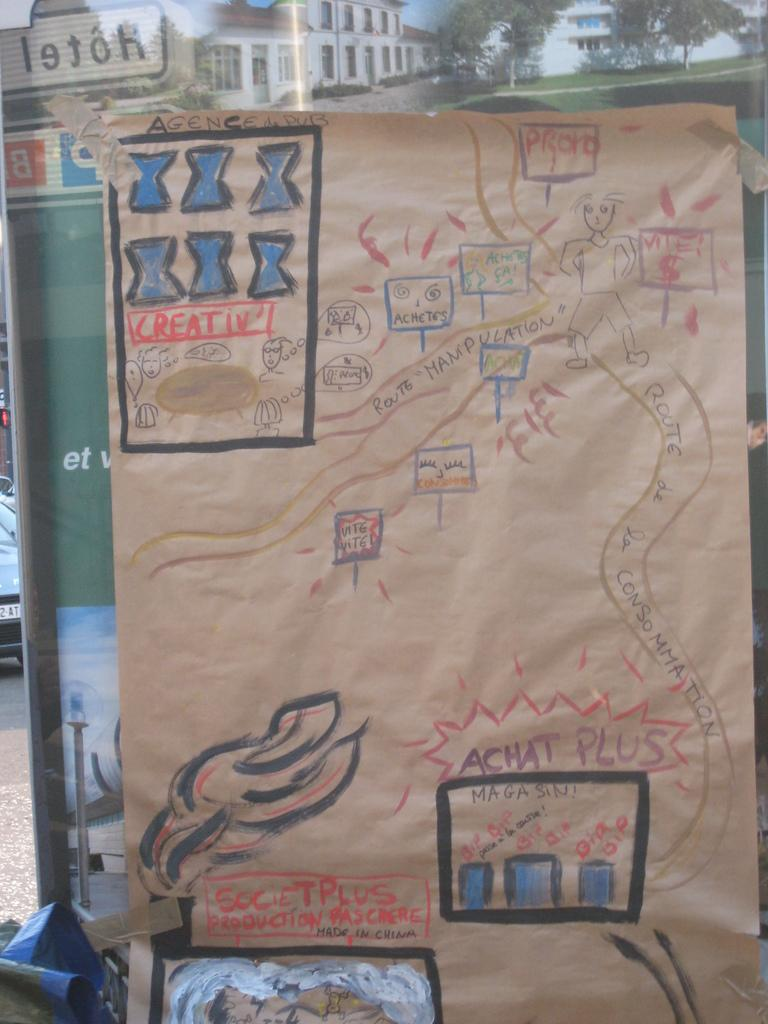<image>
Provide a brief description of the given image. a brown piece of paper with the word creative on it 